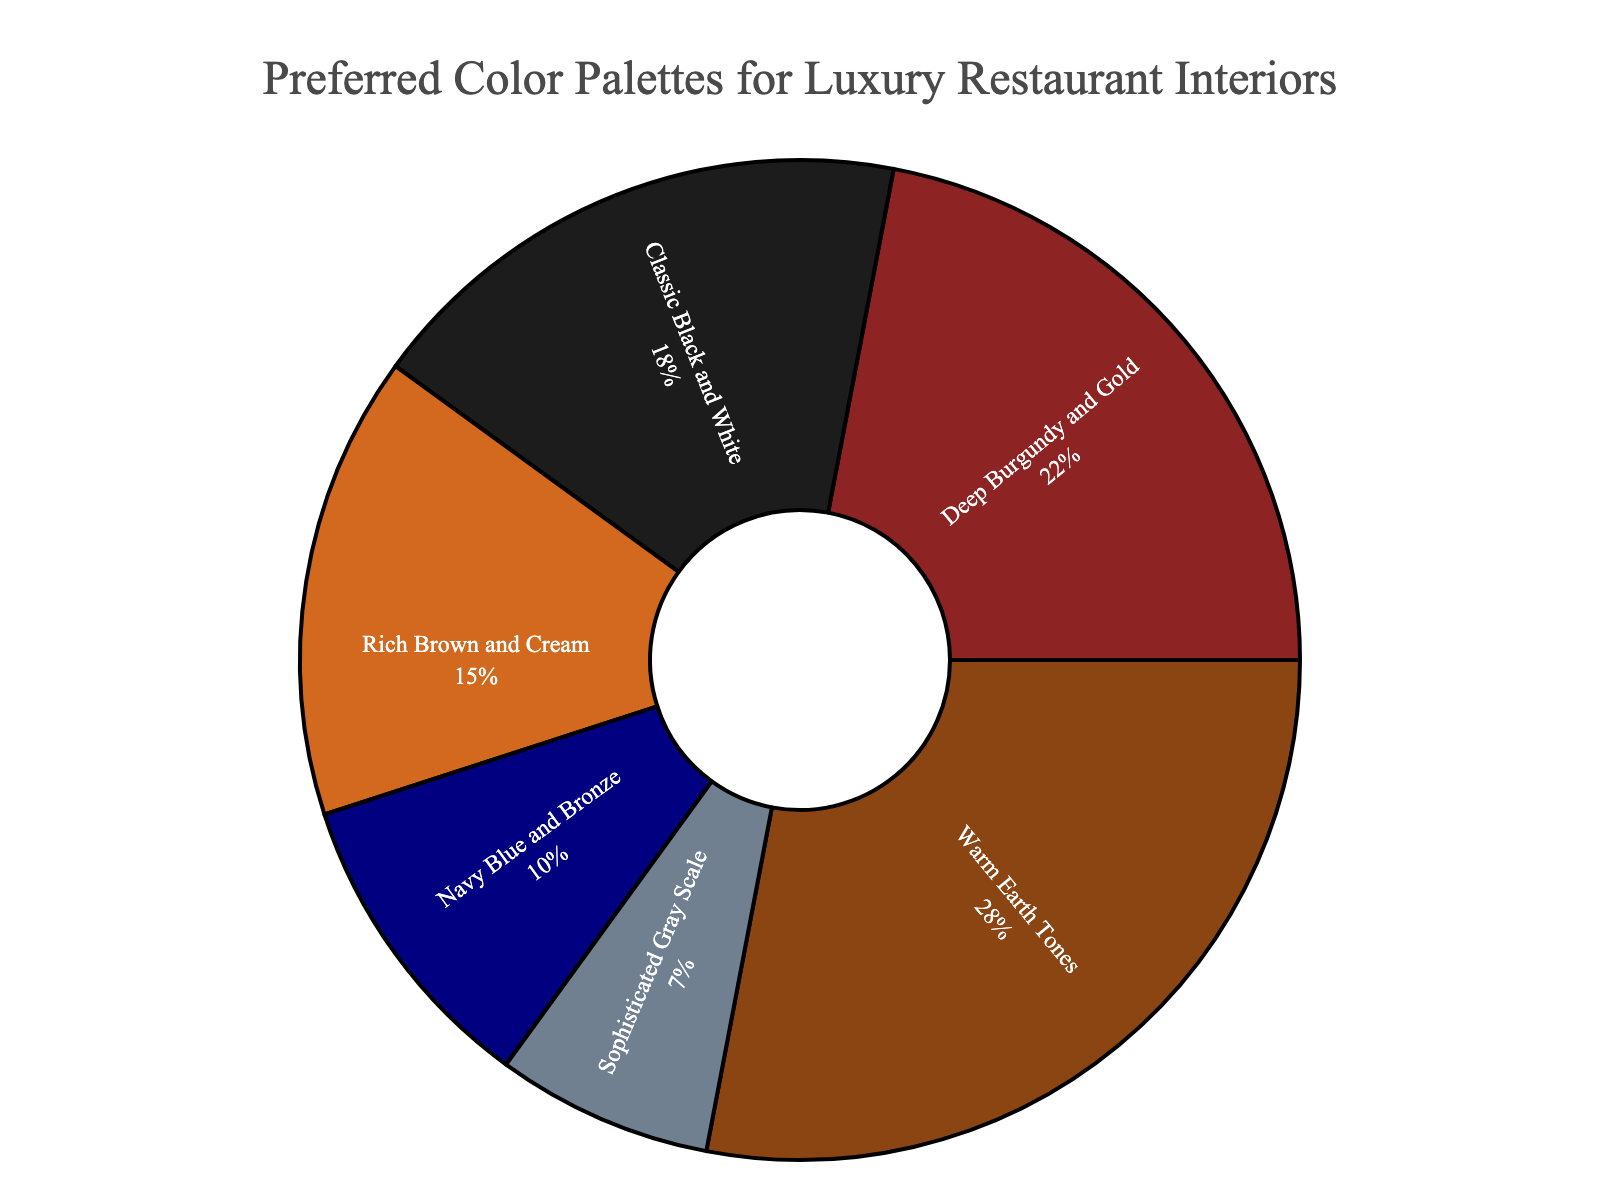What is the most popular color palette for luxury restaurant interiors? The figure shows that "Warm Earth Tones" has the highest percentage among all color palettes at 28%.
Answer: Warm Earth Tones Which color palette percentages combined make up over 50% of the preferences? Adding the percentages of the three highest preferences: Warm Earth Tones (28%) + Deep Burgundy and Gold (22%) + Classic Black and White (18%), we get a combined total of 68%, which is over 50%.
Answer: Warm Earth Tones, Deep Burgundy and Gold, Classic Black and White Is the percentage of "Navy Blue and Bronze" higher or lower than "Rich Brown and Cream"? The figure shows "Navy Blue and Bronze" at 10% and "Rich Brown and Cream" at 15%, so "Navy Blue and Bronze" is lower.
Answer: Lower Among the presented options, which color palette has the smallest percentage? The smallest segment in the pie chart represents "Sophisticated Gray Scale" at 7%.
Answer: Sophisticated Gray Scale What is the sum of the percentages of "Classic Black and White" and "Rich Brown and Cream"? Adding the percentages: Classic Black and White (18%) + Rich Brown and Cream (15%), we get 33%.
Answer: 33% What is the difference in percentage points between the most and least popular color palettes? The most popular is "Warm Earth Tones" at 28%, and the least is "Sophisticated Gray Scale" at 7%. The difference is 28% - 7% = 21%.
Answer: 21% By what factor is the percentage of "Warm Earth Tones" larger than "Sophisticated Gray Scale"? The percentage of "Warm Earth Tones" is 28% and "Sophisticated Gray Scale" is 7%. The factor is calculated as 28% / 7% = 4.
Answer: 4 How much larger is the percentage of "Deep Burgundy and Gold" compared to "Navy Blue and Bronze"? "Deep Burgundy and Gold" has 22% while "Navy Blue and Bronze" has 10%. The difference is 22% - 10% = 12%.
Answer: 12% What fraction of the total does the percentage of "Sophisticated Gray Scale" represent? The total percentage is 100%. The fraction for "Sophisticated Gray Scale" is 7% / 100% = 7/100 or 0.07.
Answer: 0.07 